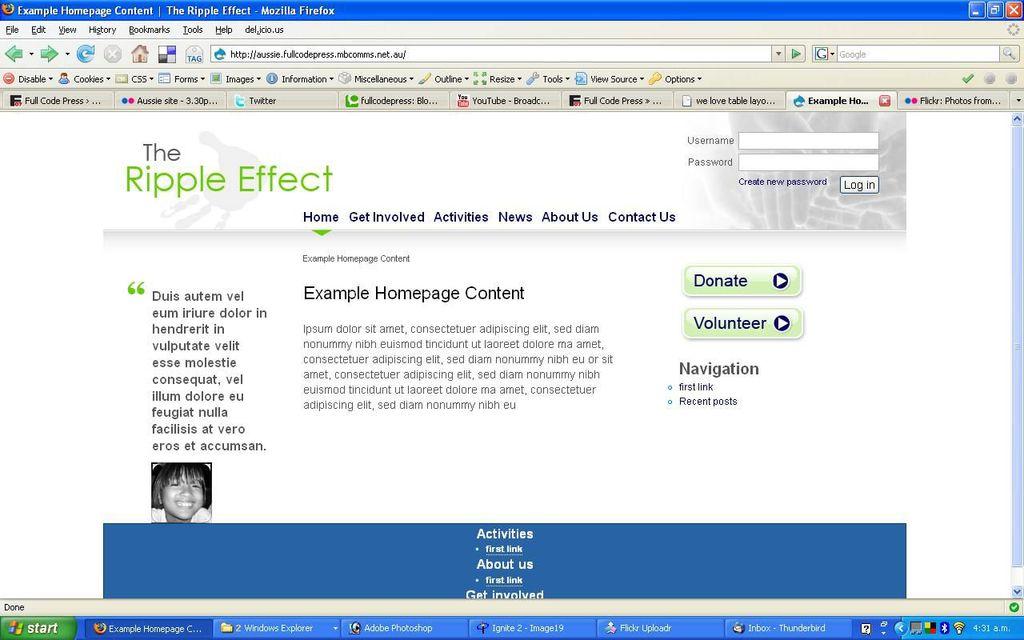Does this place belong to the ripple effect?
Ensure brevity in your answer.  Yes. One if one of the bookmarks shown?
Ensure brevity in your answer.  Youtube. 